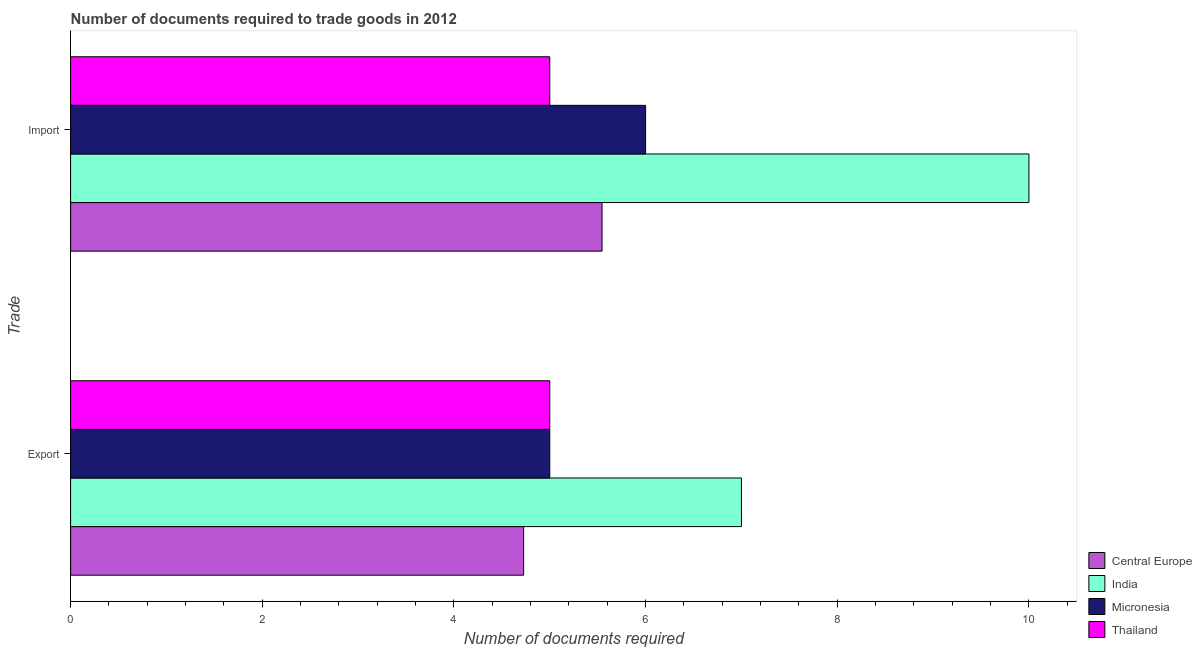How many different coloured bars are there?
Offer a terse response. 4. Are the number of bars per tick equal to the number of legend labels?
Ensure brevity in your answer.  Yes. Are the number of bars on each tick of the Y-axis equal?
Ensure brevity in your answer.  Yes. How many bars are there on the 2nd tick from the top?
Your answer should be very brief. 4. What is the label of the 1st group of bars from the top?
Provide a short and direct response. Import. Across all countries, what is the minimum number of documents required to export goods?
Ensure brevity in your answer.  4.73. In which country was the number of documents required to export goods maximum?
Your answer should be very brief. India. In which country was the number of documents required to import goods minimum?
Provide a succinct answer. Thailand. What is the total number of documents required to export goods in the graph?
Make the answer very short. 21.73. What is the difference between the number of documents required to export goods in Central Europe and that in Thailand?
Provide a succinct answer. -0.27. What is the difference between the number of documents required to export goods in India and the number of documents required to import goods in Central Europe?
Offer a very short reply. 1.45. What is the average number of documents required to import goods per country?
Make the answer very short. 6.64. In how many countries, is the number of documents required to import goods greater than 8.8 ?
Your answer should be compact. 1. What is the ratio of the number of documents required to import goods in India to that in Micronesia?
Offer a very short reply. 1.67. In how many countries, is the number of documents required to export goods greater than the average number of documents required to export goods taken over all countries?
Keep it short and to the point. 1. What does the 3rd bar from the top in Export represents?
Offer a terse response. India. How many countries are there in the graph?
Provide a short and direct response. 4. What is the difference between two consecutive major ticks on the X-axis?
Offer a terse response. 2. Are the values on the major ticks of X-axis written in scientific E-notation?
Keep it short and to the point. No. Does the graph contain any zero values?
Your answer should be very brief. No. Does the graph contain grids?
Keep it short and to the point. No. How many legend labels are there?
Your answer should be very brief. 4. What is the title of the graph?
Your response must be concise. Number of documents required to trade goods in 2012. What is the label or title of the X-axis?
Give a very brief answer. Number of documents required. What is the label or title of the Y-axis?
Offer a terse response. Trade. What is the Number of documents required in Central Europe in Export?
Make the answer very short. 4.73. What is the Number of documents required in Central Europe in Import?
Provide a short and direct response. 5.55. What is the Number of documents required of Thailand in Import?
Give a very brief answer. 5. Across all Trade, what is the maximum Number of documents required in Central Europe?
Provide a short and direct response. 5.55. Across all Trade, what is the maximum Number of documents required in India?
Your answer should be compact. 10. Across all Trade, what is the minimum Number of documents required in Central Europe?
Your answer should be very brief. 4.73. Across all Trade, what is the minimum Number of documents required in India?
Keep it short and to the point. 7. What is the total Number of documents required in Central Europe in the graph?
Give a very brief answer. 10.27. What is the total Number of documents required of India in the graph?
Provide a succinct answer. 17. What is the total Number of documents required in Thailand in the graph?
Make the answer very short. 10. What is the difference between the Number of documents required of Central Europe in Export and that in Import?
Offer a terse response. -0.82. What is the difference between the Number of documents required in Micronesia in Export and that in Import?
Your answer should be compact. -1. What is the difference between the Number of documents required of Central Europe in Export and the Number of documents required of India in Import?
Provide a succinct answer. -5.27. What is the difference between the Number of documents required of Central Europe in Export and the Number of documents required of Micronesia in Import?
Provide a short and direct response. -1.27. What is the difference between the Number of documents required in Central Europe in Export and the Number of documents required in Thailand in Import?
Make the answer very short. -0.27. What is the difference between the Number of documents required of Micronesia in Export and the Number of documents required of Thailand in Import?
Make the answer very short. 0. What is the average Number of documents required of Central Europe per Trade?
Offer a terse response. 5.14. What is the average Number of documents required of Thailand per Trade?
Your response must be concise. 5. What is the difference between the Number of documents required of Central Europe and Number of documents required of India in Export?
Your response must be concise. -2.27. What is the difference between the Number of documents required in Central Europe and Number of documents required in Micronesia in Export?
Provide a succinct answer. -0.27. What is the difference between the Number of documents required of Central Europe and Number of documents required of Thailand in Export?
Offer a terse response. -0.27. What is the difference between the Number of documents required of India and Number of documents required of Thailand in Export?
Your answer should be very brief. 2. What is the difference between the Number of documents required in Micronesia and Number of documents required in Thailand in Export?
Your answer should be compact. 0. What is the difference between the Number of documents required of Central Europe and Number of documents required of India in Import?
Ensure brevity in your answer.  -4.45. What is the difference between the Number of documents required in Central Europe and Number of documents required in Micronesia in Import?
Provide a succinct answer. -0.45. What is the difference between the Number of documents required in Central Europe and Number of documents required in Thailand in Import?
Make the answer very short. 0.55. What is the difference between the Number of documents required in India and Number of documents required in Micronesia in Import?
Ensure brevity in your answer.  4. What is the difference between the Number of documents required of Micronesia and Number of documents required of Thailand in Import?
Keep it short and to the point. 1. What is the ratio of the Number of documents required in Central Europe in Export to that in Import?
Your response must be concise. 0.85. What is the ratio of the Number of documents required of India in Export to that in Import?
Ensure brevity in your answer.  0.7. What is the ratio of the Number of documents required of Thailand in Export to that in Import?
Provide a short and direct response. 1. What is the difference between the highest and the second highest Number of documents required in Central Europe?
Provide a succinct answer. 0.82. What is the difference between the highest and the second highest Number of documents required in Micronesia?
Ensure brevity in your answer.  1. What is the difference between the highest and the lowest Number of documents required of Central Europe?
Offer a very short reply. 0.82. What is the difference between the highest and the lowest Number of documents required of Thailand?
Provide a succinct answer. 0. 